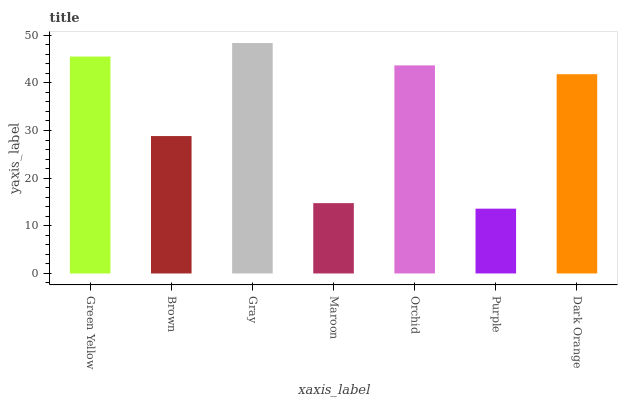Is Brown the minimum?
Answer yes or no. No. Is Brown the maximum?
Answer yes or no. No. Is Green Yellow greater than Brown?
Answer yes or no. Yes. Is Brown less than Green Yellow?
Answer yes or no. Yes. Is Brown greater than Green Yellow?
Answer yes or no. No. Is Green Yellow less than Brown?
Answer yes or no. No. Is Dark Orange the high median?
Answer yes or no. Yes. Is Dark Orange the low median?
Answer yes or no. Yes. Is Green Yellow the high median?
Answer yes or no. No. Is Brown the low median?
Answer yes or no. No. 